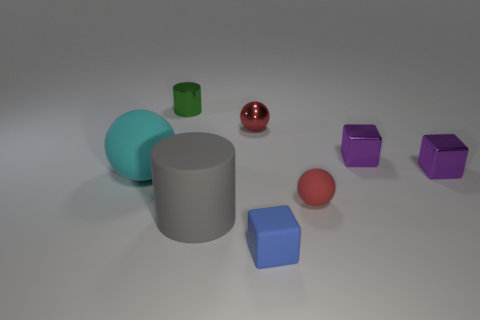Add 1 purple matte objects. How many objects exist? 9 Subtract all cylinders. How many objects are left? 6 Subtract 0 brown blocks. How many objects are left? 8 Subtract all big purple cylinders. Subtract all big gray cylinders. How many objects are left? 7 Add 6 gray rubber things. How many gray rubber things are left? 7 Add 5 small blue rubber cubes. How many small blue rubber cubes exist? 6 